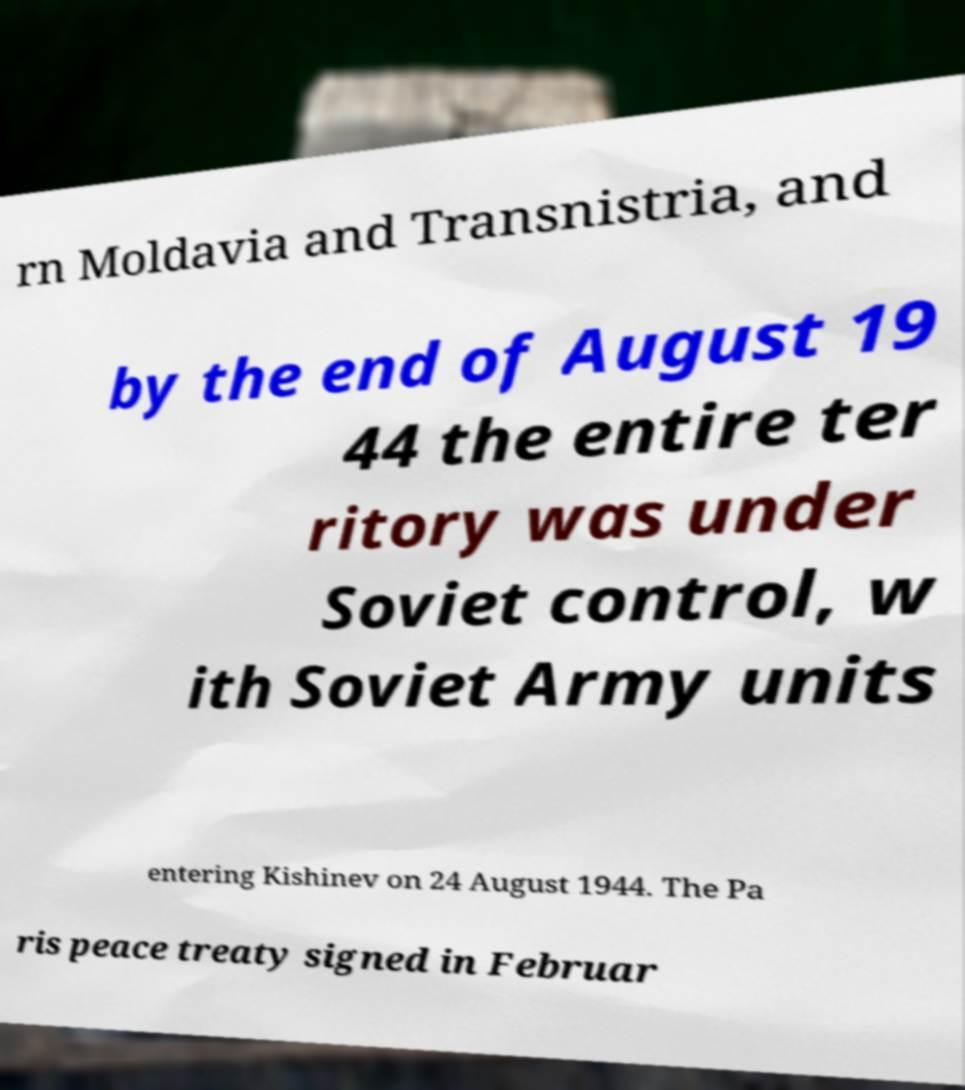Could you assist in decoding the text presented in this image and type it out clearly? rn Moldavia and Transnistria, and by the end of August 19 44 the entire ter ritory was under Soviet control, w ith Soviet Army units entering Kishinev on 24 August 1944. The Pa ris peace treaty signed in Februar 